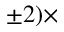<formula> <loc_0><loc_0><loc_500><loc_500>\pm 2 ) \times</formula> 